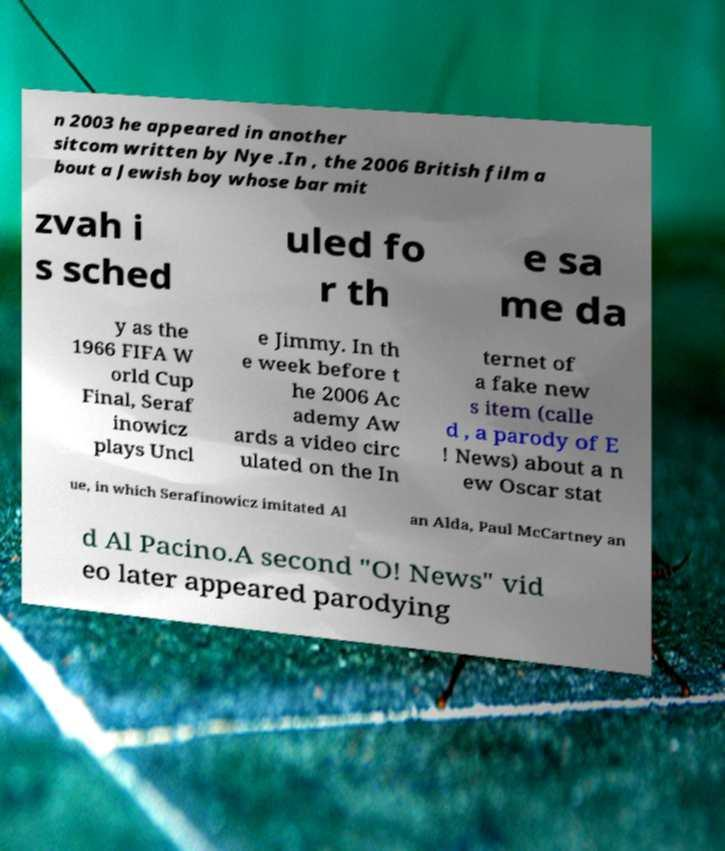I need the written content from this picture converted into text. Can you do that? n 2003 he appeared in another sitcom written by Nye .In , the 2006 British film a bout a Jewish boy whose bar mit zvah i s sched uled fo r th e sa me da y as the 1966 FIFA W orld Cup Final, Seraf inowicz plays Uncl e Jimmy. In th e week before t he 2006 Ac ademy Aw ards a video circ ulated on the In ternet of a fake new s item (calle d , a parody of E ! News) about a n ew Oscar stat ue, in which Serafinowicz imitated Al an Alda, Paul McCartney an d Al Pacino.A second "O! News" vid eo later appeared parodying 